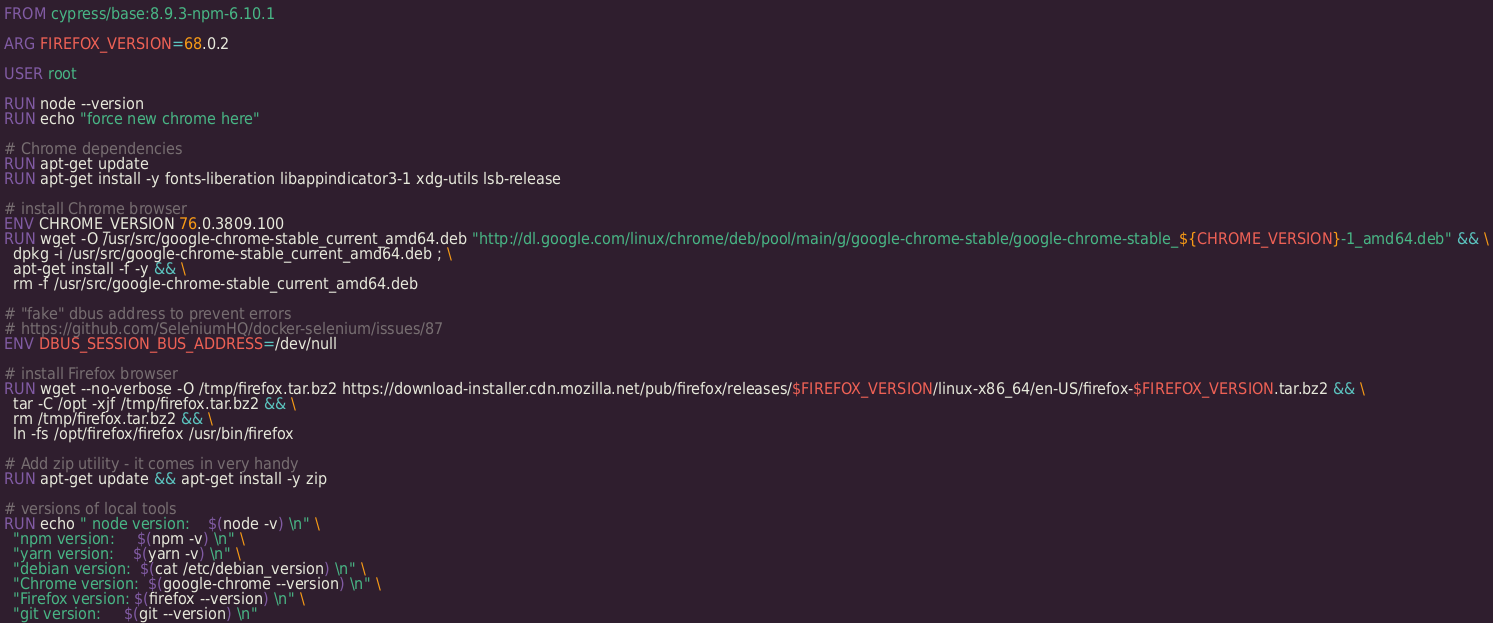<code> <loc_0><loc_0><loc_500><loc_500><_Dockerfile_>FROM cypress/base:8.9.3-npm-6.10.1

ARG FIREFOX_VERSION=68.0.2

USER root

RUN node --version
RUN echo "force new chrome here"

# Chrome dependencies
RUN apt-get update
RUN apt-get install -y fonts-liberation libappindicator3-1 xdg-utils lsb-release

# install Chrome browser
ENV CHROME_VERSION 76.0.3809.100
RUN wget -O /usr/src/google-chrome-stable_current_amd64.deb "http://dl.google.com/linux/chrome/deb/pool/main/g/google-chrome-stable/google-chrome-stable_${CHROME_VERSION}-1_amd64.deb" && \
  dpkg -i /usr/src/google-chrome-stable_current_amd64.deb ; \
  apt-get install -f -y && \
  rm -f /usr/src/google-chrome-stable_current_amd64.deb

# "fake" dbus address to prevent errors
# https://github.com/SeleniumHQ/docker-selenium/issues/87
ENV DBUS_SESSION_BUS_ADDRESS=/dev/null

# install Firefox browser
RUN wget --no-verbose -O /tmp/firefox.tar.bz2 https://download-installer.cdn.mozilla.net/pub/firefox/releases/$FIREFOX_VERSION/linux-x86_64/en-US/firefox-$FIREFOX_VERSION.tar.bz2 && \
  tar -C /opt -xjf /tmp/firefox.tar.bz2 && \
  rm /tmp/firefox.tar.bz2 && \
  ln -fs /opt/firefox/firefox /usr/bin/firefox

# Add zip utility - it comes in very handy
RUN apt-get update && apt-get install -y zip

# versions of local tools
RUN echo " node version:    $(node -v) \n" \
  "npm version:     $(npm -v) \n" \
  "yarn version:    $(yarn -v) \n" \
  "debian version:  $(cat /etc/debian_version) \n" \
  "Chrome version:  $(google-chrome --version) \n" \
  "Firefox version: $(firefox --version) \n" \
  "git version:     $(git --version) \n"
</code> 